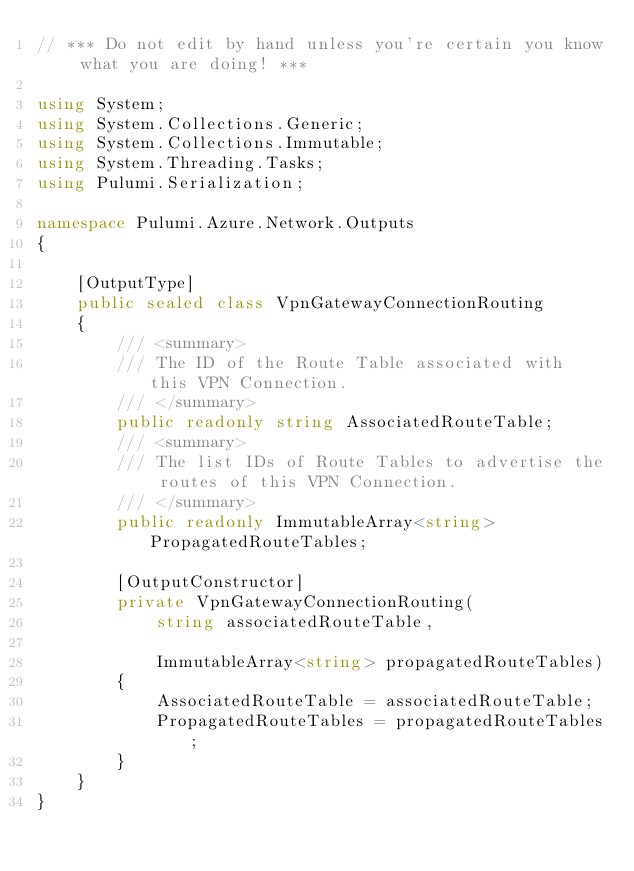Convert code to text. <code><loc_0><loc_0><loc_500><loc_500><_C#_>// *** Do not edit by hand unless you're certain you know what you are doing! ***

using System;
using System.Collections.Generic;
using System.Collections.Immutable;
using System.Threading.Tasks;
using Pulumi.Serialization;

namespace Pulumi.Azure.Network.Outputs
{

    [OutputType]
    public sealed class VpnGatewayConnectionRouting
    {
        /// <summary>
        /// The ID of the Route Table associated with this VPN Connection.
        /// </summary>
        public readonly string AssociatedRouteTable;
        /// <summary>
        /// The list IDs of Route Tables to advertise the routes of this VPN Connection.
        /// </summary>
        public readonly ImmutableArray<string> PropagatedRouteTables;

        [OutputConstructor]
        private VpnGatewayConnectionRouting(
            string associatedRouteTable,

            ImmutableArray<string> propagatedRouteTables)
        {
            AssociatedRouteTable = associatedRouteTable;
            PropagatedRouteTables = propagatedRouteTables;
        }
    }
}
</code> 